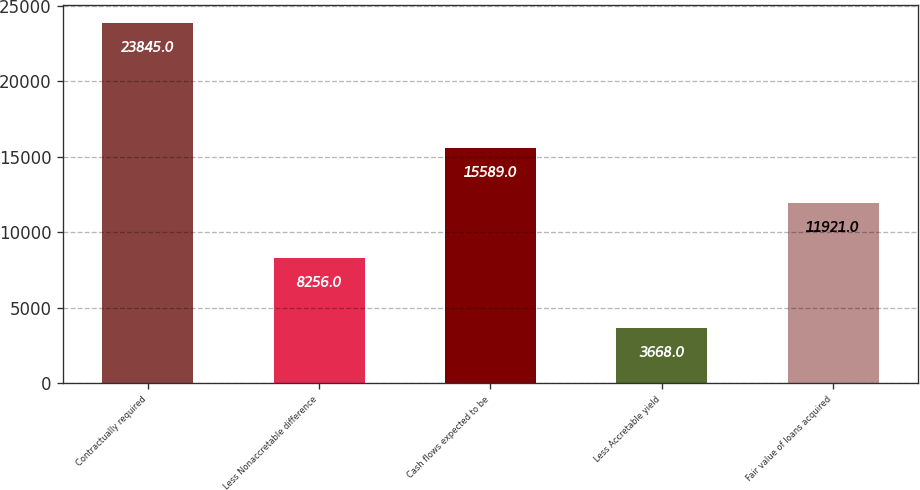<chart> <loc_0><loc_0><loc_500><loc_500><bar_chart><fcel>Contractually required<fcel>Less Nonaccretable difference<fcel>Cash flows expected to be<fcel>Less Accretable yield<fcel>Fair value of loans acquired<nl><fcel>23845<fcel>8256<fcel>15589<fcel>3668<fcel>11921<nl></chart> 